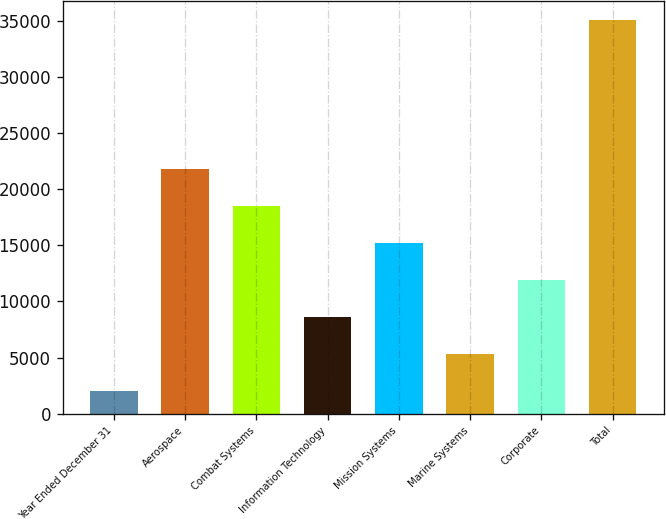Convert chart. <chart><loc_0><loc_0><loc_500><loc_500><bar_chart><fcel>Year Ended December 31<fcel>Aerospace<fcel>Combat Systems<fcel>Information Technology<fcel>Mission Systems<fcel>Marine Systems<fcel>Corporate<fcel>Total<nl><fcel>2017<fcel>21834.4<fcel>18531.5<fcel>8622.8<fcel>15228.6<fcel>5319.9<fcel>11925.7<fcel>35046<nl></chart> 